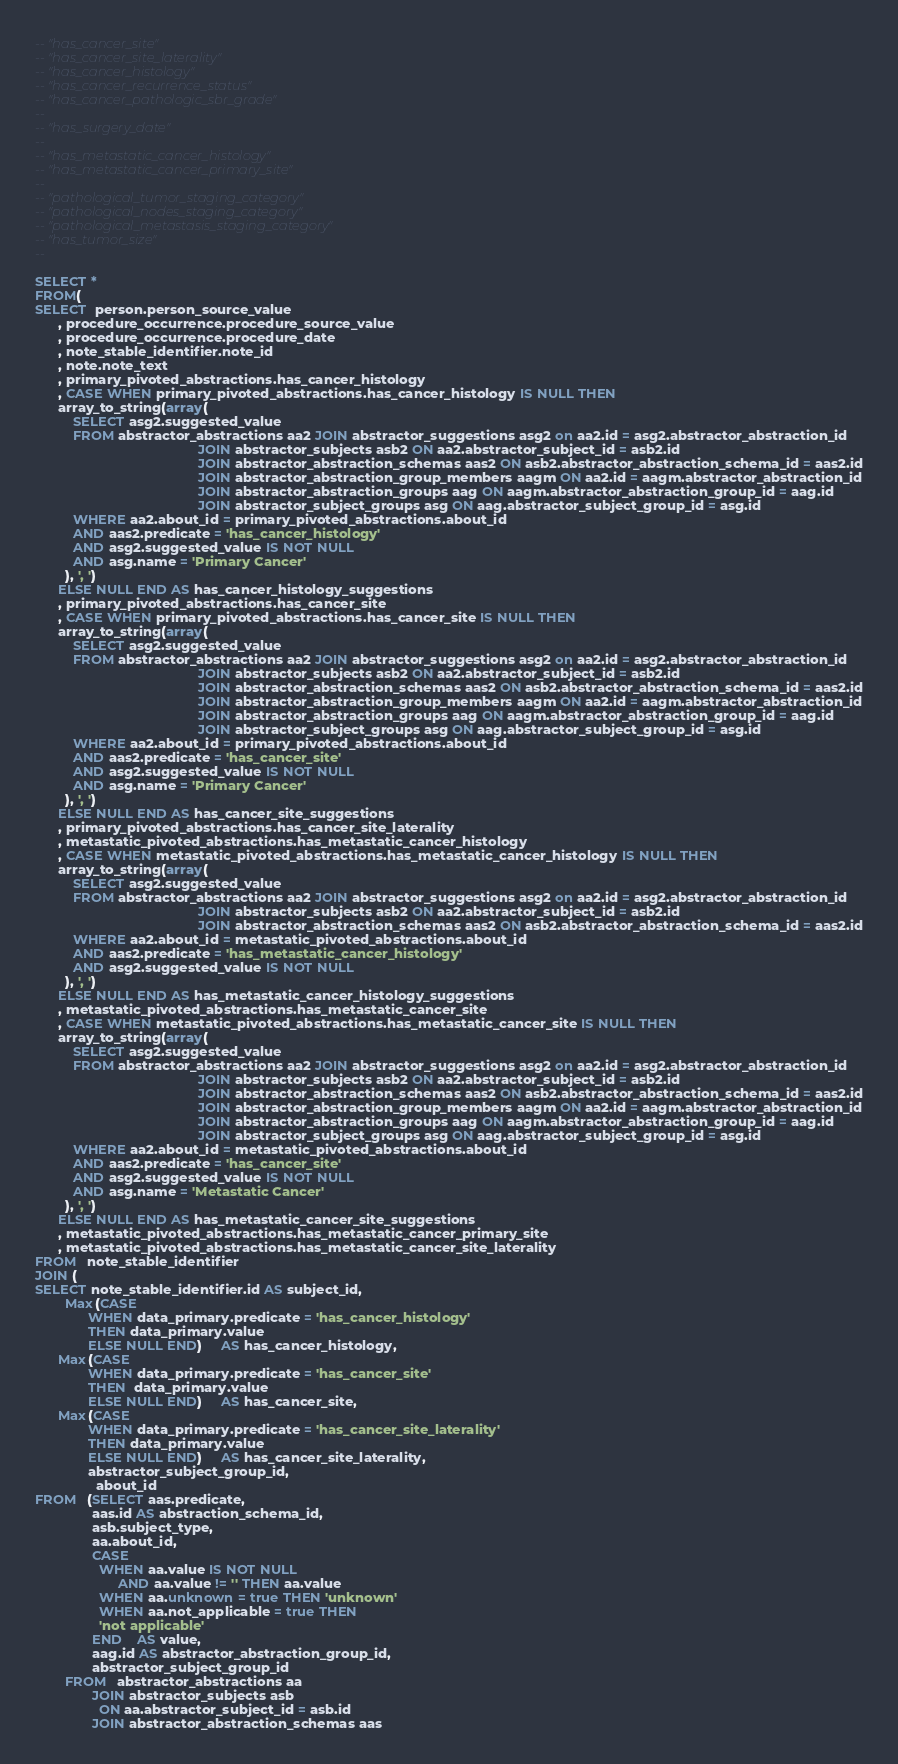Convert code to text. <code><loc_0><loc_0><loc_500><loc_500><_SQL_>-- "has_cancer_site"
-- "has_cancer_site_laterality"
-- "has_cancer_histology"
-- "has_cancer_recurrence_status"
-- "has_cancer_pathologic_sbr_grade"
--
-- "has_surgery_date"
--
-- "has_metastatic_cancer_histology"
-- "has_metastatic_cancer_primary_site"
--
-- "pathological_tumor_staging_category"
-- "pathological_nodes_staging_category"
-- "pathological_metastasis_staging_category"
-- "has_tumor_size"
--

SELECT *
FROM(
SELECT  person.person_source_value
      , procedure_occurrence.procedure_source_value
      , procedure_occurrence.procedure_date
      , note_stable_identifier.note_id
      , note.note_text
      , primary_pivoted_abstractions.has_cancer_histology
      , CASE WHEN primary_pivoted_abstractions.has_cancer_histology IS NULL THEN
      array_to_string(array(
          SELECT asg2.suggested_value
          FROM abstractor_abstractions aa2 JOIN abstractor_suggestions asg2 on aa2.id = asg2.abstractor_abstraction_id
                                           JOIN abstractor_subjects asb2 ON aa2.abstractor_subject_id = asb2.id
                                           JOIN abstractor_abstraction_schemas aas2 ON asb2.abstractor_abstraction_schema_id = aas2.id
                                           JOIN abstractor_abstraction_group_members aagm ON aa2.id = aagm.abstractor_abstraction_id
                                           JOIN abstractor_abstraction_groups aag ON aagm.abstractor_abstraction_group_id = aag.id
                                           JOIN abstractor_subject_groups asg ON aag.abstractor_subject_group_id = asg.id
          WHERE aa2.about_id = primary_pivoted_abstractions.about_id
          AND aas2.predicate = 'has_cancer_histology'
          AND asg2.suggested_value IS NOT NULL
          AND asg.name = 'Primary Cancer'
        ), ', ')
      ELSE NULL END AS has_cancer_histology_suggestions
      , primary_pivoted_abstractions.has_cancer_site
      , CASE WHEN primary_pivoted_abstractions.has_cancer_site IS NULL THEN
      array_to_string(array(
          SELECT asg2.suggested_value
          FROM abstractor_abstractions aa2 JOIN abstractor_suggestions asg2 on aa2.id = asg2.abstractor_abstraction_id
                                           JOIN abstractor_subjects asb2 ON aa2.abstractor_subject_id = asb2.id
                                           JOIN abstractor_abstraction_schemas aas2 ON asb2.abstractor_abstraction_schema_id = aas2.id
                                           JOIN abstractor_abstraction_group_members aagm ON aa2.id = aagm.abstractor_abstraction_id
                                           JOIN abstractor_abstraction_groups aag ON aagm.abstractor_abstraction_group_id = aag.id
                                           JOIN abstractor_subject_groups asg ON aag.abstractor_subject_group_id = asg.id
          WHERE aa2.about_id = primary_pivoted_abstractions.about_id
          AND aas2.predicate = 'has_cancer_site'
          AND asg2.suggested_value IS NOT NULL
          AND asg.name = 'Primary Cancer'
        ), ', ')
      ELSE NULL END AS has_cancer_site_suggestions
      , primary_pivoted_abstractions.has_cancer_site_laterality
      , metastatic_pivoted_abstractions.has_metastatic_cancer_histology
      , CASE WHEN metastatic_pivoted_abstractions.has_metastatic_cancer_histology IS NULL THEN
      array_to_string(array(
          SELECT asg2.suggested_value
          FROM abstractor_abstractions aa2 JOIN abstractor_suggestions asg2 on aa2.id = asg2.abstractor_abstraction_id
                                           JOIN abstractor_subjects asb2 ON aa2.abstractor_subject_id = asb2.id
                                           JOIN abstractor_abstraction_schemas aas2 ON asb2.abstractor_abstraction_schema_id = aas2.id
          WHERE aa2.about_id = metastatic_pivoted_abstractions.about_id
          AND aas2.predicate = 'has_metastatic_cancer_histology'
          AND asg2.suggested_value IS NOT NULL
        ), ', ')
      ELSE NULL END AS has_metastatic_cancer_histology_suggestions
      , metastatic_pivoted_abstractions.has_metastatic_cancer_site
      , CASE WHEN metastatic_pivoted_abstractions.has_metastatic_cancer_site IS NULL THEN
      array_to_string(array(
          SELECT asg2.suggested_value
          FROM abstractor_abstractions aa2 JOIN abstractor_suggestions asg2 on aa2.id = asg2.abstractor_abstraction_id
                                           JOIN abstractor_subjects asb2 ON aa2.abstractor_subject_id = asb2.id
                                           JOIN abstractor_abstraction_schemas aas2 ON asb2.abstractor_abstraction_schema_id = aas2.id
                                           JOIN abstractor_abstraction_group_members aagm ON aa2.id = aagm.abstractor_abstraction_id
                                           JOIN abstractor_abstraction_groups aag ON aagm.abstractor_abstraction_group_id = aag.id
                                           JOIN abstractor_subject_groups asg ON aag.abstractor_subject_group_id = asg.id
          WHERE aa2.about_id = metastatic_pivoted_abstractions.about_id
          AND aas2.predicate = 'has_cancer_site'
          AND asg2.suggested_value IS NOT NULL
          AND asg.name = 'Metastatic Cancer'
        ), ', ')
      ELSE NULL END AS has_metastatic_cancer_site_suggestions
      , metastatic_pivoted_abstractions.has_metastatic_cancer_primary_site
      , metastatic_pivoted_abstractions.has_metastatic_cancer_site_laterality
FROM   note_stable_identifier
JOIN (
SELECT note_stable_identifier.id AS subject_id,
        Max(CASE
              WHEN data_primary.predicate = 'has_cancer_histology'
              THEN data_primary.value
              ELSE NULL END)     AS has_cancer_histology,
      Max(CASE
              WHEN data_primary.predicate = 'has_cancer_site'
              THEN  data_primary.value
              ELSE NULL END)     AS has_cancer_site,
      Max(CASE
              WHEN data_primary.predicate = 'has_cancer_site_laterality'
              THEN data_primary.value
              ELSE NULL END)     AS has_cancer_site_laterality,
              abstractor_subject_group_id,
	            about_id
FROM   (SELECT aas.predicate,
               aas.id AS abstraction_schema_id,
               asb.subject_type,
               aa.about_id,
               CASE
                 WHEN aa.value IS NOT NULL
                      AND aa.value != '' THEN aa.value
                 WHEN aa.unknown = true THEN 'unknown'
                 WHEN aa.not_applicable = true THEN
                 'not applicable'
               END    AS value,
               aag.id AS abstractor_abstraction_group_id,
               abstractor_subject_group_id
        FROM   abstractor_abstractions aa
               JOIN abstractor_subjects asb
                 ON aa.abstractor_subject_id = asb.id
               JOIN abstractor_abstraction_schemas aas</code> 